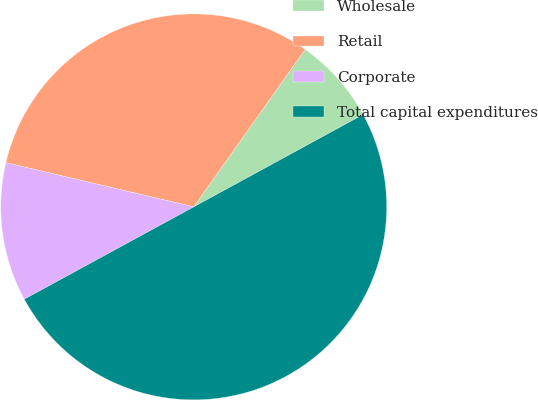<chart> <loc_0><loc_0><loc_500><loc_500><pie_chart><fcel>Wholesale<fcel>Retail<fcel>Corporate<fcel>Total capital expenditures<nl><fcel>7.25%<fcel>31.12%<fcel>11.62%<fcel>50.0%<nl></chart> 